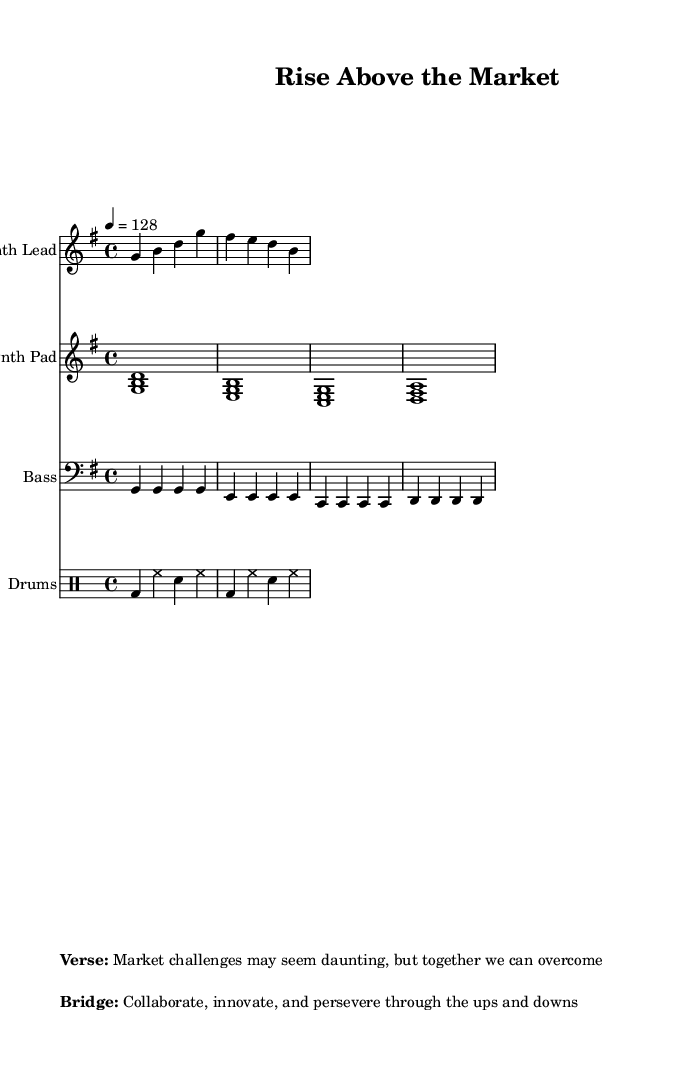What is the key signature of this music? The key signature is G major, which has one sharp (F#). You can find the key indicated at the beginning of the staff.
Answer: G major What is the time signature of this piece? The time signature is 4/4, indicating four beats per measure. This is also shown at the beginning of the music.
Answer: 4/4 What is the tempo marking for this composition? The tempo marking shows that the piece should be played at a speed of 128 beats per minute, which is noted as "4 = 128" at the beginning.
Answer: 128 How many measures are in the Synth Lead part? The Synth Lead part consists of 2 measures, which can be counted from the provided notes indicating the start and end of each measure.
Answer: 2 What is the rhythm pattern of the drums? The rhythm pattern consists of kick drum (bd), hi-hat (hh), and snare (sn) sounds, aligning with a typical electronic beat structure, detailed in the rhythmic notation.
Answer: bd4 hh sn hh In the motivational spoken word, what is the primary message? The primary message is about overcoming market challenges together and promoting collaboration and innovation, highlighted in the verse and bridge lyrics.
Answer: Overcome What type of synthesizer sound is used as the lead instrument? The lead instrument is a Synth Lead, typically used in electronic music for melodic lines. You can identify this based on the notation above the staff.
Answer: Synth Lead 